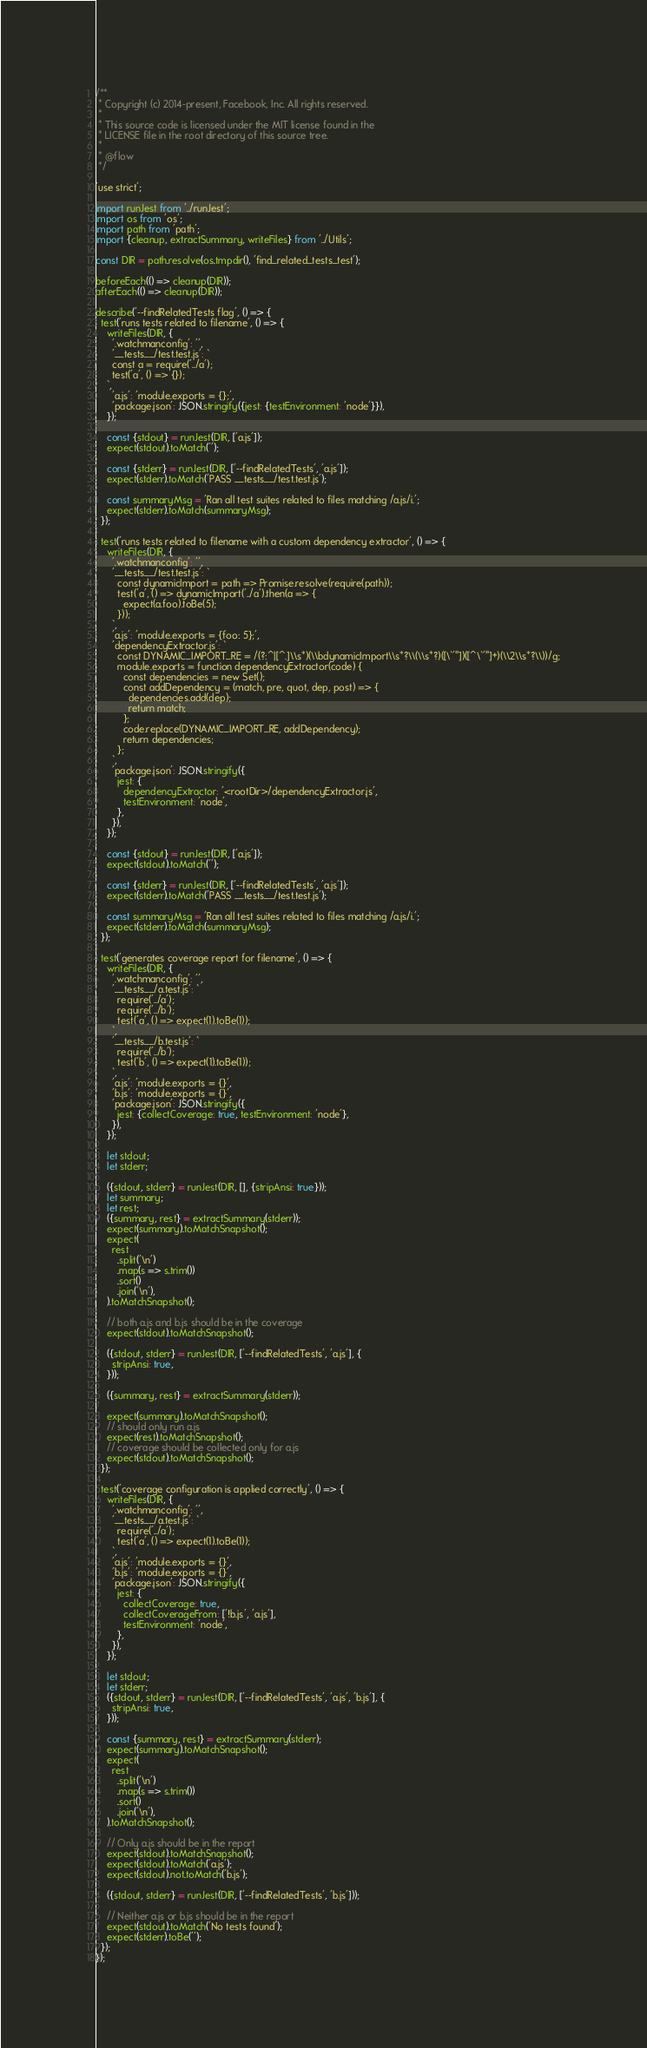Convert code to text. <code><loc_0><loc_0><loc_500><loc_500><_JavaScript_>/**
 * Copyright (c) 2014-present, Facebook, Inc. All rights reserved.
 *
 * This source code is licensed under the MIT license found in the
 * LICENSE file in the root directory of this source tree.
 *
 * @flow
 */

'use strict';

import runJest from '../runJest';
import os from 'os';
import path from 'path';
import {cleanup, extractSummary, writeFiles} from '../Utils';

const DIR = path.resolve(os.tmpdir(), 'find_related_tests_test');

beforeEach(() => cleanup(DIR));
afterEach(() => cleanup(DIR));

describe('--findRelatedTests flag', () => {
  test('runs tests related to filename', () => {
    writeFiles(DIR, {
      '.watchmanconfig': '',
      '__tests__/test.test.js': `
      const a = require('../a');
      test('a', () => {});
    `,
      'a.js': 'module.exports = {};',
      'package.json': JSON.stringify({jest: {testEnvironment: 'node'}}),
    });

    const {stdout} = runJest(DIR, ['a.js']);
    expect(stdout).toMatch('');

    const {stderr} = runJest(DIR, ['--findRelatedTests', 'a.js']);
    expect(stderr).toMatch('PASS __tests__/test.test.js');

    const summaryMsg = 'Ran all test suites related to files matching /a.js/i.';
    expect(stderr).toMatch(summaryMsg);
  });

  test('runs tests related to filename with a custom dependency extractor', () => {
    writeFiles(DIR, {
      '.watchmanconfig': '',
      '__tests__/test.test.js': `
        const dynamicImport = path => Promise.resolve(require(path));
        test('a', () => dynamicImport('../a').then(a => {
          expect(a.foo).toBe(5);
        }));
      `,
      'a.js': 'module.exports = {foo: 5};',
      'dependencyExtractor.js': `
        const DYNAMIC_IMPORT_RE = /(?:^|[^.]\\s*)(\\bdynamicImport\\s*?\\(\\s*?)([\`'"])([^\`'"]+)(\\2\\s*?\\))/g;
        module.exports = function dependencyExtractor(code) {
          const dependencies = new Set();
          const addDependency = (match, pre, quot, dep, post) => {
            dependencies.add(dep);
            return match;
          };
          code.replace(DYNAMIC_IMPORT_RE, addDependency);
          return dependencies;
        };
      `,
      'package.json': JSON.stringify({
        jest: {
          dependencyExtractor: '<rootDir>/dependencyExtractor.js',
          testEnvironment: 'node',
        },
      }),
    });

    const {stdout} = runJest(DIR, ['a.js']);
    expect(stdout).toMatch('');

    const {stderr} = runJest(DIR, ['--findRelatedTests', 'a.js']);
    expect(stderr).toMatch('PASS __tests__/test.test.js');

    const summaryMsg = 'Ran all test suites related to files matching /a.js/i.';
    expect(stderr).toMatch(summaryMsg);
  });

  test('generates coverage report for filename', () => {
    writeFiles(DIR, {
      '.watchmanconfig': '',
      '__tests__/a.test.js': `
        require('../a');
        require('../b');
        test('a', () => expect(1).toBe(1));
      `,
      '__tests__/b.test.js': `
        require('../b');
        test('b', () => expect(1).toBe(1));
      `,
      'a.js': 'module.exports = {}',
      'b.js': 'module.exports = {}',
      'package.json': JSON.stringify({
        jest: {collectCoverage: true, testEnvironment: 'node'},
      }),
    });

    let stdout;
    let stderr;

    ({stdout, stderr} = runJest(DIR, [], {stripAnsi: true}));
    let summary;
    let rest;
    ({summary, rest} = extractSummary(stderr));
    expect(summary).toMatchSnapshot();
    expect(
      rest
        .split('\n')
        .map(s => s.trim())
        .sort()
        .join('\n'),
    ).toMatchSnapshot();

    // both a.js and b.js should be in the coverage
    expect(stdout).toMatchSnapshot();

    ({stdout, stderr} = runJest(DIR, ['--findRelatedTests', 'a.js'], {
      stripAnsi: true,
    }));

    ({summary, rest} = extractSummary(stderr));

    expect(summary).toMatchSnapshot();
    // should only run a.js
    expect(rest).toMatchSnapshot();
    // coverage should be collected only for a.js
    expect(stdout).toMatchSnapshot();
  });

  test('coverage configuration is applied correctly', () => {
    writeFiles(DIR, {
      '.watchmanconfig': '',
      '__tests__/a.test.js': `
        require('../a');
        test('a', () => expect(1).toBe(1));
      `,
      'a.js': 'module.exports = {}',
      'b.js': 'module.exports = {}',
      'package.json': JSON.stringify({
        jest: {
          collectCoverage: true,
          collectCoverageFrom: ['!b.js', 'a.js'],
          testEnvironment: 'node',
        },
      }),
    });

    let stdout;
    let stderr;
    ({stdout, stderr} = runJest(DIR, ['--findRelatedTests', 'a.js', 'b.js'], {
      stripAnsi: true,
    }));

    const {summary, rest} = extractSummary(stderr);
    expect(summary).toMatchSnapshot();
    expect(
      rest
        .split('\n')
        .map(s => s.trim())
        .sort()
        .join('\n'),
    ).toMatchSnapshot();

    // Only a.js should be in the report
    expect(stdout).toMatchSnapshot();
    expect(stdout).toMatch('a.js');
    expect(stdout).not.toMatch('b.js');

    ({stdout, stderr} = runJest(DIR, ['--findRelatedTests', 'b.js']));

    // Neither a.js or b.js should be in the report
    expect(stdout).toMatch('No tests found');
    expect(stderr).toBe('');
  });
});
</code> 